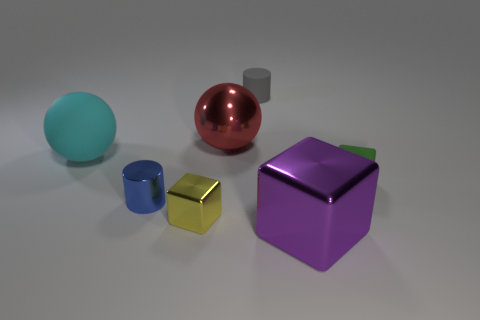Subtract all cyan cylinders. Subtract all gray blocks. How many cylinders are left? 2 Add 2 big brown spheres. How many objects exist? 9 Subtract all spheres. How many objects are left? 5 Subtract 0 red cylinders. How many objects are left? 7 Subtract all tiny shiny things. Subtract all gray things. How many objects are left? 4 Add 2 big shiny spheres. How many big shiny spheres are left? 3 Add 3 spheres. How many spheres exist? 5 